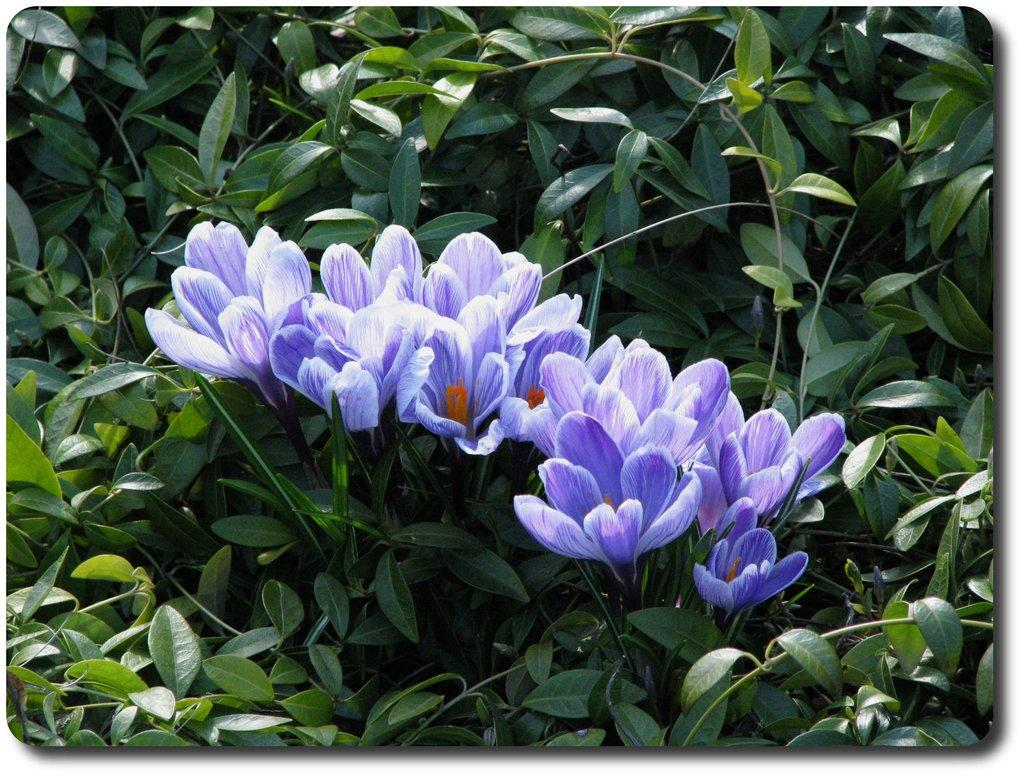What types of living organisms can be seen in the image? Plants and flowers are visible in the image. Can you describe the specific flora present in the image? The image contains plants and flowers, but the specific types cannot be determined without more information. How many sticks can be seen supporting the flowers in the image? There are no sticks present in the image; it only contains plants and flowers. 